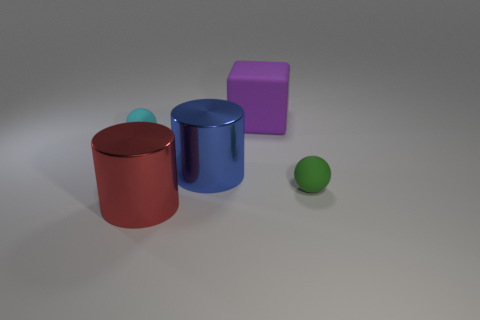Add 3 green matte balls. How many objects exist? 8 Subtract all balls. How many objects are left? 3 Add 1 purple balls. How many purple balls exist? 1 Subtract 0 blue spheres. How many objects are left? 5 Subtract all big yellow matte objects. Subtract all tiny cyan rubber spheres. How many objects are left? 4 Add 3 blue metallic things. How many blue metallic things are left? 4 